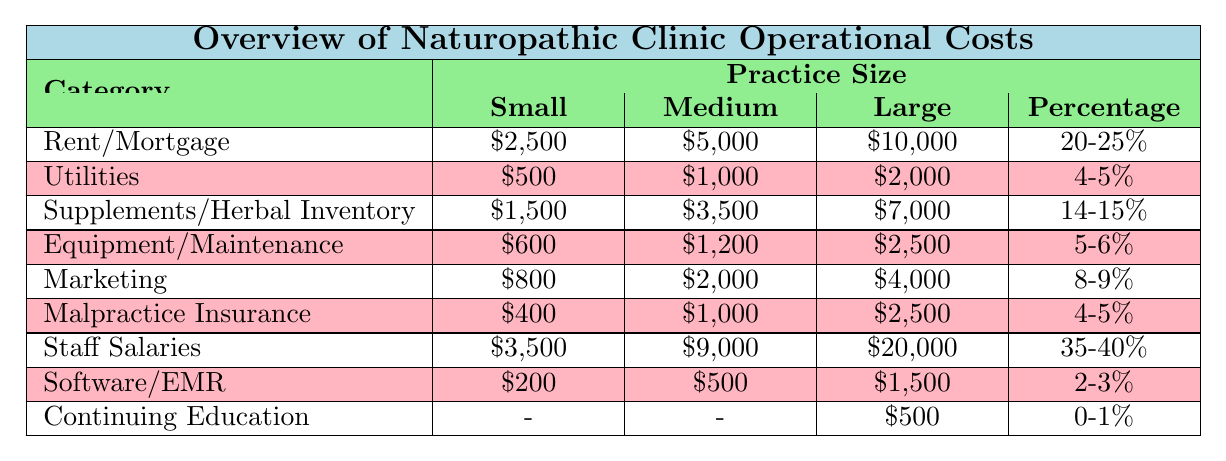What is the total monthly cost for a small practice? To find the total monthly cost for a small practice, sum the monthly costs for each category: $2,500 (Rent) + $500 (Utilities) + $1,500 (Supplements) + $600 (Equipment) + $800 (Marketing) + $400 (Insurance) + $3,500 (Salaries) + $200 (Software) = $10,100.
Answer: $10,100 Which category has the highest percentage of total costs for small practices? From the table, Staff Salaries for small practices is listed at 35%, which is higher than any other category.
Answer: Staff Salaries Is the monthly cost for utilities higher in medium or large practices? The monthly cost for utilities is $1,000 for medium practices and $2,000 for large practices. Since $2,000 is greater than $1,000, the monthly cost for utilities is higher in large practices.
Answer: Yes What is the average monthly cost for marketing across all practice sizes? Calculate the average by first finding the total marketing costs: $800 (Small) + $2,000 (Medium) + $4,000 (Large) = $6,800. There are 3 practice sizes, so divide by 3: $6,800 / 3 = $2,266.67.
Answer: $2,266.67 How much does the cost for supplements/herbal inventory increase from small to large practices? The cost for small practices is $1,500 and for large practices is $7,000. The increase is calculated by subtracting: $7,000 - $1,500 = $5,500.
Answer: $5,500 What percentage of total costs does malpractice insurance represent in medium-sized practices? Malpractice insurance costs $1,000 per month for medium practices, which represents 4% of total costs as indicated in the table.
Answer: 4% Which category has the lowest annual cost for large practices? The lowest annual cost in large practices is listed for Continuing Education at $6,000.
Answer: Continuing Education If a medium practice reduces its staff salaries by $3,000, what would be its new monthly total cost? Current Staff Salaries for medium practices are $9,000. Reducing by $3,000 gives $9,000 - $3,000 = $6,000. The new monthly total cost would be: $5,000 (Rent) + $1,000 (Utilities) + $3,500 (Supplements) + $1,200 (Equipment) + $2,000 (Marketing) + $1,000 (Insurance) + $6,000 (Salaries) + $500 (Software) = $20,200.
Answer: $20,200 Is the combined monthly cost for utilities and marketing higher in small or medium practices? For small practices, combined costs are $500 (Utilities) + $800 (Marketing) = $1,300. For medium practices, it's $1,000 (Utilities) + $2,000 (Marketing) = $3,000. Since $3,000 is greater than $1,300, medium practices have higher combined costs.
Answer: Medium practices What is the total percentage of costs dedicated to staff salaries across all practice sizes? Add the percentages for staff salaries: 35% (Small) + 39% (Medium) + 40% (Large) = 114%. Since there are 3 practice sizes, divide by 3 to find average percentage: 114% / 3 = 38%.
Answer: 38% 